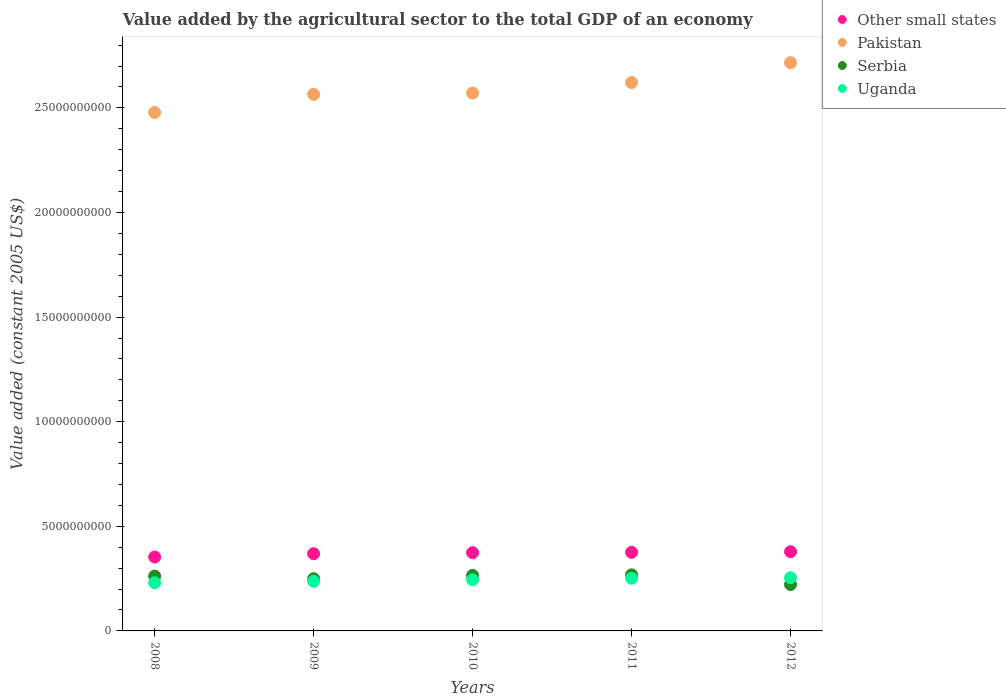How many different coloured dotlines are there?
Offer a very short reply. 4. Is the number of dotlines equal to the number of legend labels?
Provide a succinct answer. Yes. What is the value added by the agricultural sector in Pakistan in 2010?
Offer a very short reply. 2.57e+1. Across all years, what is the maximum value added by the agricultural sector in Pakistan?
Offer a terse response. 2.72e+1. Across all years, what is the minimum value added by the agricultural sector in Pakistan?
Your answer should be very brief. 2.48e+1. In which year was the value added by the agricultural sector in Other small states maximum?
Offer a very short reply. 2012. What is the total value added by the agricultural sector in Pakistan in the graph?
Provide a short and direct response. 1.30e+11. What is the difference between the value added by the agricultural sector in Uganda in 2009 and that in 2011?
Keep it short and to the point. -1.46e+08. What is the difference between the value added by the agricultural sector in Pakistan in 2011 and the value added by the agricultural sector in Other small states in 2008?
Provide a succinct answer. 2.27e+1. What is the average value added by the agricultural sector in Serbia per year?
Keep it short and to the point. 2.53e+09. In the year 2008, what is the difference between the value added by the agricultural sector in Other small states and value added by the agricultural sector in Serbia?
Your response must be concise. 9.11e+08. What is the ratio of the value added by the agricultural sector in Other small states in 2009 to that in 2010?
Give a very brief answer. 0.99. Is the difference between the value added by the agricultural sector in Other small states in 2010 and 2012 greater than the difference between the value added by the agricultural sector in Serbia in 2010 and 2012?
Your answer should be compact. No. What is the difference between the highest and the second highest value added by the agricultural sector in Serbia?
Make the answer very short. 2.52e+07. What is the difference between the highest and the lowest value added by the agricultural sector in Uganda?
Your answer should be compact. 2.40e+08. Is the sum of the value added by the agricultural sector in Serbia in 2011 and 2012 greater than the maximum value added by the agricultural sector in Pakistan across all years?
Provide a short and direct response. No. Is it the case that in every year, the sum of the value added by the agricultural sector in Pakistan and value added by the agricultural sector in Serbia  is greater than the sum of value added by the agricultural sector in Uganda and value added by the agricultural sector in Other small states?
Your answer should be very brief. Yes. Does the value added by the agricultural sector in Uganda monotonically increase over the years?
Ensure brevity in your answer.  Yes. Is the value added by the agricultural sector in Other small states strictly less than the value added by the agricultural sector in Uganda over the years?
Offer a very short reply. No. How many dotlines are there?
Your answer should be very brief. 4. Where does the legend appear in the graph?
Keep it short and to the point. Top right. How are the legend labels stacked?
Give a very brief answer. Vertical. What is the title of the graph?
Give a very brief answer. Value added by the agricultural sector to the total GDP of an economy. Does "OECD members" appear as one of the legend labels in the graph?
Keep it short and to the point. No. What is the label or title of the Y-axis?
Provide a short and direct response. Value added (constant 2005 US$). What is the Value added (constant 2005 US$) in Other small states in 2008?
Provide a succinct answer. 3.53e+09. What is the Value added (constant 2005 US$) of Pakistan in 2008?
Provide a short and direct response. 2.48e+1. What is the Value added (constant 2005 US$) in Serbia in 2008?
Keep it short and to the point. 2.62e+09. What is the Value added (constant 2005 US$) of Uganda in 2008?
Give a very brief answer. 2.30e+09. What is the Value added (constant 2005 US$) in Other small states in 2009?
Provide a succinct answer. 3.69e+09. What is the Value added (constant 2005 US$) in Pakistan in 2009?
Keep it short and to the point. 2.56e+1. What is the Value added (constant 2005 US$) of Serbia in 2009?
Give a very brief answer. 2.50e+09. What is the Value added (constant 2005 US$) in Uganda in 2009?
Provide a succinct answer. 2.37e+09. What is the Value added (constant 2005 US$) in Other small states in 2010?
Your response must be concise. 3.74e+09. What is the Value added (constant 2005 US$) of Pakistan in 2010?
Your answer should be compact. 2.57e+1. What is the Value added (constant 2005 US$) of Serbia in 2010?
Make the answer very short. 2.66e+09. What is the Value added (constant 2005 US$) in Uganda in 2010?
Offer a terse response. 2.45e+09. What is the Value added (constant 2005 US$) of Other small states in 2011?
Keep it short and to the point. 3.76e+09. What is the Value added (constant 2005 US$) in Pakistan in 2011?
Ensure brevity in your answer.  2.62e+1. What is the Value added (constant 2005 US$) in Serbia in 2011?
Provide a succinct answer. 2.68e+09. What is the Value added (constant 2005 US$) of Uganda in 2011?
Provide a short and direct response. 2.52e+09. What is the Value added (constant 2005 US$) of Other small states in 2012?
Offer a terse response. 3.79e+09. What is the Value added (constant 2005 US$) in Pakistan in 2012?
Ensure brevity in your answer.  2.72e+1. What is the Value added (constant 2005 US$) in Serbia in 2012?
Make the answer very short. 2.22e+09. What is the Value added (constant 2005 US$) in Uganda in 2012?
Offer a terse response. 2.54e+09. Across all years, what is the maximum Value added (constant 2005 US$) of Other small states?
Keep it short and to the point. 3.79e+09. Across all years, what is the maximum Value added (constant 2005 US$) of Pakistan?
Your response must be concise. 2.72e+1. Across all years, what is the maximum Value added (constant 2005 US$) in Serbia?
Provide a short and direct response. 2.68e+09. Across all years, what is the maximum Value added (constant 2005 US$) of Uganda?
Provide a short and direct response. 2.54e+09. Across all years, what is the minimum Value added (constant 2005 US$) in Other small states?
Provide a short and direct response. 3.53e+09. Across all years, what is the minimum Value added (constant 2005 US$) of Pakistan?
Make the answer very short. 2.48e+1. Across all years, what is the minimum Value added (constant 2005 US$) of Serbia?
Keep it short and to the point. 2.22e+09. Across all years, what is the minimum Value added (constant 2005 US$) of Uganda?
Your response must be concise. 2.30e+09. What is the total Value added (constant 2005 US$) of Other small states in the graph?
Offer a very short reply. 1.85e+1. What is the total Value added (constant 2005 US$) of Pakistan in the graph?
Your answer should be very brief. 1.30e+11. What is the total Value added (constant 2005 US$) in Serbia in the graph?
Provide a short and direct response. 1.27e+1. What is the total Value added (constant 2005 US$) of Uganda in the graph?
Make the answer very short. 1.22e+1. What is the difference between the Value added (constant 2005 US$) of Other small states in 2008 and that in 2009?
Offer a terse response. -1.59e+08. What is the difference between the Value added (constant 2005 US$) of Pakistan in 2008 and that in 2009?
Keep it short and to the point. -8.67e+08. What is the difference between the Value added (constant 2005 US$) of Serbia in 2008 and that in 2009?
Make the answer very short. 1.25e+08. What is the difference between the Value added (constant 2005 US$) in Uganda in 2008 and that in 2009?
Your answer should be very brief. -6.66e+07. What is the difference between the Value added (constant 2005 US$) of Other small states in 2008 and that in 2010?
Provide a short and direct response. -2.07e+08. What is the difference between the Value added (constant 2005 US$) in Pakistan in 2008 and that in 2010?
Give a very brief answer. -9.26e+08. What is the difference between the Value added (constant 2005 US$) of Serbia in 2008 and that in 2010?
Make the answer very short. -3.45e+07. What is the difference between the Value added (constant 2005 US$) of Uganda in 2008 and that in 2010?
Provide a succinct answer. -1.42e+08. What is the difference between the Value added (constant 2005 US$) in Other small states in 2008 and that in 2011?
Ensure brevity in your answer.  -2.24e+08. What is the difference between the Value added (constant 2005 US$) in Pakistan in 2008 and that in 2011?
Offer a terse response. -1.43e+09. What is the difference between the Value added (constant 2005 US$) of Serbia in 2008 and that in 2011?
Ensure brevity in your answer.  -5.97e+07. What is the difference between the Value added (constant 2005 US$) of Uganda in 2008 and that in 2011?
Ensure brevity in your answer.  -2.13e+08. What is the difference between the Value added (constant 2005 US$) in Other small states in 2008 and that in 2012?
Your answer should be very brief. -2.54e+08. What is the difference between the Value added (constant 2005 US$) of Pakistan in 2008 and that in 2012?
Ensure brevity in your answer.  -2.38e+09. What is the difference between the Value added (constant 2005 US$) of Serbia in 2008 and that in 2012?
Your response must be concise. 4.04e+08. What is the difference between the Value added (constant 2005 US$) in Uganda in 2008 and that in 2012?
Keep it short and to the point. -2.40e+08. What is the difference between the Value added (constant 2005 US$) of Other small states in 2009 and that in 2010?
Give a very brief answer. -4.82e+07. What is the difference between the Value added (constant 2005 US$) in Pakistan in 2009 and that in 2010?
Offer a very short reply. -5.89e+07. What is the difference between the Value added (constant 2005 US$) in Serbia in 2009 and that in 2010?
Provide a short and direct response. -1.59e+08. What is the difference between the Value added (constant 2005 US$) in Uganda in 2009 and that in 2010?
Your response must be concise. -7.50e+07. What is the difference between the Value added (constant 2005 US$) of Other small states in 2009 and that in 2011?
Make the answer very short. -6.47e+07. What is the difference between the Value added (constant 2005 US$) of Pakistan in 2009 and that in 2011?
Give a very brief answer. -5.63e+08. What is the difference between the Value added (constant 2005 US$) of Serbia in 2009 and that in 2011?
Make the answer very short. -1.85e+08. What is the difference between the Value added (constant 2005 US$) of Uganda in 2009 and that in 2011?
Your answer should be compact. -1.46e+08. What is the difference between the Value added (constant 2005 US$) in Other small states in 2009 and that in 2012?
Ensure brevity in your answer.  -9.50e+07. What is the difference between the Value added (constant 2005 US$) in Pakistan in 2009 and that in 2012?
Give a very brief answer. -1.51e+09. What is the difference between the Value added (constant 2005 US$) in Serbia in 2009 and that in 2012?
Ensure brevity in your answer.  2.79e+08. What is the difference between the Value added (constant 2005 US$) of Uganda in 2009 and that in 2012?
Give a very brief answer. -1.74e+08. What is the difference between the Value added (constant 2005 US$) of Other small states in 2010 and that in 2011?
Offer a very short reply. -1.65e+07. What is the difference between the Value added (constant 2005 US$) of Pakistan in 2010 and that in 2011?
Make the answer very short. -5.04e+08. What is the difference between the Value added (constant 2005 US$) in Serbia in 2010 and that in 2011?
Provide a succinct answer. -2.52e+07. What is the difference between the Value added (constant 2005 US$) in Uganda in 2010 and that in 2011?
Offer a very short reply. -7.14e+07. What is the difference between the Value added (constant 2005 US$) of Other small states in 2010 and that in 2012?
Your response must be concise. -4.68e+07. What is the difference between the Value added (constant 2005 US$) of Pakistan in 2010 and that in 2012?
Your answer should be very brief. -1.45e+09. What is the difference between the Value added (constant 2005 US$) of Serbia in 2010 and that in 2012?
Offer a terse response. 4.38e+08. What is the difference between the Value added (constant 2005 US$) in Uganda in 2010 and that in 2012?
Your answer should be compact. -9.88e+07. What is the difference between the Value added (constant 2005 US$) in Other small states in 2011 and that in 2012?
Your answer should be very brief. -3.03e+07. What is the difference between the Value added (constant 2005 US$) of Pakistan in 2011 and that in 2012?
Your answer should be very brief. -9.49e+08. What is the difference between the Value added (constant 2005 US$) of Serbia in 2011 and that in 2012?
Your answer should be very brief. 4.64e+08. What is the difference between the Value added (constant 2005 US$) in Uganda in 2011 and that in 2012?
Keep it short and to the point. -2.74e+07. What is the difference between the Value added (constant 2005 US$) in Other small states in 2008 and the Value added (constant 2005 US$) in Pakistan in 2009?
Offer a terse response. -2.21e+1. What is the difference between the Value added (constant 2005 US$) of Other small states in 2008 and the Value added (constant 2005 US$) of Serbia in 2009?
Your answer should be compact. 1.04e+09. What is the difference between the Value added (constant 2005 US$) of Other small states in 2008 and the Value added (constant 2005 US$) of Uganda in 2009?
Keep it short and to the point. 1.16e+09. What is the difference between the Value added (constant 2005 US$) of Pakistan in 2008 and the Value added (constant 2005 US$) of Serbia in 2009?
Provide a succinct answer. 2.23e+1. What is the difference between the Value added (constant 2005 US$) in Pakistan in 2008 and the Value added (constant 2005 US$) in Uganda in 2009?
Your answer should be very brief. 2.24e+1. What is the difference between the Value added (constant 2005 US$) of Serbia in 2008 and the Value added (constant 2005 US$) of Uganda in 2009?
Your response must be concise. 2.51e+08. What is the difference between the Value added (constant 2005 US$) of Other small states in 2008 and the Value added (constant 2005 US$) of Pakistan in 2010?
Your answer should be very brief. -2.22e+1. What is the difference between the Value added (constant 2005 US$) of Other small states in 2008 and the Value added (constant 2005 US$) of Serbia in 2010?
Ensure brevity in your answer.  8.77e+08. What is the difference between the Value added (constant 2005 US$) in Other small states in 2008 and the Value added (constant 2005 US$) in Uganda in 2010?
Provide a short and direct response. 1.09e+09. What is the difference between the Value added (constant 2005 US$) of Pakistan in 2008 and the Value added (constant 2005 US$) of Serbia in 2010?
Provide a short and direct response. 2.21e+1. What is the difference between the Value added (constant 2005 US$) in Pakistan in 2008 and the Value added (constant 2005 US$) in Uganda in 2010?
Give a very brief answer. 2.23e+1. What is the difference between the Value added (constant 2005 US$) in Serbia in 2008 and the Value added (constant 2005 US$) in Uganda in 2010?
Make the answer very short. 1.76e+08. What is the difference between the Value added (constant 2005 US$) in Other small states in 2008 and the Value added (constant 2005 US$) in Pakistan in 2011?
Provide a short and direct response. -2.27e+1. What is the difference between the Value added (constant 2005 US$) of Other small states in 2008 and the Value added (constant 2005 US$) of Serbia in 2011?
Offer a very short reply. 8.52e+08. What is the difference between the Value added (constant 2005 US$) of Other small states in 2008 and the Value added (constant 2005 US$) of Uganda in 2011?
Give a very brief answer. 1.02e+09. What is the difference between the Value added (constant 2005 US$) in Pakistan in 2008 and the Value added (constant 2005 US$) in Serbia in 2011?
Offer a terse response. 2.21e+1. What is the difference between the Value added (constant 2005 US$) in Pakistan in 2008 and the Value added (constant 2005 US$) in Uganda in 2011?
Your response must be concise. 2.23e+1. What is the difference between the Value added (constant 2005 US$) of Serbia in 2008 and the Value added (constant 2005 US$) of Uganda in 2011?
Provide a short and direct response. 1.04e+08. What is the difference between the Value added (constant 2005 US$) in Other small states in 2008 and the Value added (constant 2005 US$) in Pakistan in 2012?
Keep it short and to the point. -2.36e+1. What is the difference between the Value added (constant 2005 US$) in Other small states in 2008 and the Value added (constant 2005 US$) in Serbia in 2012?
Provide a short and direct response. 1.32e+09. What is the difference between the Value added (constant 2005 US$) in Other small states in 2008 and the Value added (constant 2005 US$) in Uganda in 2012?
Make the answer very short. 9.88e+08. What is the difference between the Value added (constant 2005 US$) in Pakistan in 2008 and the Value added (constant 2005 US$) in Serbia in 2012?
Your answer should be very brief. 2.26e+1. What is the difference between the Value added (constant 2005 US$) in Pakistan in 2008 and the Value added (constant 2005 US$) in Uganda in 2012?
Make the answer very short. 2.22e+1. What is the difference between the Value added (constant 2005 US$) in Serbia in 2008 and the Value added (constant 2005 US$) in Uganda in 2012?
Your answer should be compact. 7.69e+07. What is the difference between the Value added (constant 2005 US$) in Other small states in 2009 and the Value added (constant 2005 US$) in Pakistan in 2010?
Give a very brief answer. -2.20e+1. What is the difference between the Value added (constant 2005 US$) in Other small states in 2009 and the Value added (constant 2005 US$) in Serbia in 2010?
Offer a very short reply. 1.04e+09. What is the difference between the Value added (constant 2005 US$) in Other small states in 2009 and the Value added (constant 2005 US$) in Uganda in 2010?
Ensure brevity in your answer.  1.25e+09. What is the difference between the Value added (constant 2005 US$) in Pakistan in 2009 and the Value added (constant 2005 US$) in Serbia in 2010?
Ensure brevity in your answer.  2.30e+1. What is the difference between the Value added (constant 2005 US$) of Pakistan in 2009 and the Value added (constant 2005 US$) of Uganda in 2010?
Your answer should be compact. 2.32e+1. What is the difference between the Value added (constant 2005 US$) of Serbia in 2009 and the Value added (constant 2005 US$) of Uganda in 2010?
Your answer should be compact. 5.08e+07. What is the difference between the Value added (constant 2005 US$) in Other small states in 2009 and the Value added (constant 2005 US$) in Pakistan in 2011?
Your response must be concise. -2.25e+1. What is the difference between the Value added (constant 2005 US$) of Other small states in 2009 and the Value added (constant 2005 US$) of Serbia in 2011?
Give a very brief answer. 1.01e+09. What is the difference between the Value added (constant 2005 US$) of Other small states in 2009 and the Value added (constant 2005 US$) of Uganda in 2011?
Ensure brevity in your answer.  1.17e+09. What is the difference between the Value added (constant 2005 US$) in Pakistan in 2009 and the Value added (constant 2005 US$) in Serbia in 2011?
Give a very brief answer. 2.30e+1. What is the difference between the Value added (constant 2005 US$) in Pakistan in 2009 and the Value added (constant 2005 US$) in Uganda in 2011?
Ensure brevity in your answer.  2.31e+1. What is the difference between the Value added (constant 2005 US$) in Serbia in 2009 and the Value added (constant 2005 US$) in Uganda in 2011?
Provide a short and direct response. -2.07e+07. What is the difference between the Value added (constant 2005 US$) of Other small states in 2009 and the Value added (constant 2005 US$) of Pakistan in 2012?
Your answer should be compact. -2.35e+1. What is the difference between the Value added (constant 2005 US$) in Other small states in 2009 and the Value added (constant 2005 US$) in Serbia in 2012?
Provide a short and direct response. 1.47e+09. What is the difference between the Value added (constant 2005 US$) in Other small states in 2009 and the Value added (constant 2005 US$) in Uganda in 2012?
Offer a very short reply. 1.15e+09. What is the difference between the Value added (constant 2005 US$) of Pakistan in 2009 and the Value added (constant 2005 US$) of Serbia in 2012?
Offer a very short reply. 2.34e+1. What is the difference between the Value added (constant 2005 US$) in Pakistan in 2009 and the Value added (constant 2005 US$) in Uganda in 2012?
Your response must be concise. 2.31e+1. What is the difference between the Value added (constant 2005 US$) in Serbia in 2009 and the Value added (constant 2005 US$) in Uganda in 2012?
Your answer should be compact. -4.81e+07. What is the difference between the Value added (constant 2005 US$) in Other small states in 2010 and the Value added (constant 2005 US$) in Pakistan in 2011?
Make the answer very short. -2.25e+1. What is the difference between the Value added (constant 2005 US$) of Other small states in 2010 and the Value added (constant 2005 US$) of Serbia in 2011?
Keep it short and to the point. 1.06e+09. What is the difference between the Value added (constant 2005 US$) of Other small states in 2010 and the Value added (constant 2005 US$) of Uganda in 2011?
Provide a succinct answer. 1.22e+09. What is the difference between the Value added (constant 2005 US$) in Pakistan in 2010 and the Value added (constant 2005 US$) in Serbia in 2011?
Your answer should be very brief. 2.30e+1. What is the difference between the Value added (constant 2005 US$) of Pakistan in 2010 and the Value added (constant 2005 US$) of Uganda in 2011?
Keep it short and to the point. 2.32e+1. What is the difference between the Value added (constant 2005 US$) of Serbia in 2010 and the Value added (constant 2005 US$) of Uganda in 2011?
Your response must be concise. 1.39e+08. What is the difference between the Value added (constant 2005 US$) of Other small states in 2010 and the Value added (constant 2005 US$) of Pakistan in 2012?
Offer a very short reply. -2.34e+1. What is the difference between the Value added (constant 2005 US$) in Other small states in 2010 and the Value added (constant 2005 US$) in Serbia in 2012?
Offer a terse response. 1.52e+09. What is the difference between the Value added (constant 2005 US$) of Other small states in 2010 and the Value added (constant 2005 US$) of Uganda in 2012?
Make the answer very short. 1.20e+09. What is the difference between the Value added (constant 2005 US$) in Pakistan in 2010 and the Value added (constant 2005 US$) in Serbia in 2012?
Make the answer very short. 2.35e+1. What is the difference between the Value added (constant 2005 US$) of Pakistan in 2010 and the Value added (constant 2005 US$) of Uganda in 2012?
Offer a very short reply. 2.32e+1. What is the difference between the Value added (constant 2005 US$) of Serbia in 2010 and the Value added (constant 2005 US$) of Uganda in 2012?
Provide a succinct answer. 1.11e+08. What is the difference between the Value added (constant 2005 US$) of Other small states in 2011 and the Value added (constant 2005 US$) of Pakistan in 2012?
Keep it short and to the point. -2.34e+1. What is the difference between the Value added (constant 2005 US$) in Other small states in 2011 and the Value added (constant 2005 US$) in Serbia in 2012?
Your response must be concise. 1.54e+09. What is the difference between the Value added (constant 2005 US$) in Other small states in 2011 and the Value added (constant 2005 US$) in Uganda in 2012?
Offer a terse response. 1.21e+09. What is the difference between the Value added (constant 2005 US$) of Pakistan in 2011 and the Value added (constant 2005 US$) of Serbia in 2012?
Provide a short and direct response. 2.40e+1. What is the difference between the Value added (constant 2005 US$) of Pakistan in 2011 and the Value added (constant 2005 US$) of Uganda in 2012?
Provide a succinct answer. 2.37e+1. What is the difference between the Value added (constant 2005 US$) of Serbia in 2011 and the Value added (constant 2005 US$) of Uganda in 2012?
Keep it short and to the point. 1.37e+08. What is the average Value added (constant 2005 US$) in Other small states per year?
Your answer should be very brief. 3.70e+09. What is the average Value added (constant 2005 US$) in Pakistan per year?
Make the answer very short. 2.59e+1. What is the average Value added (constant 2005 US$) in Serbia per year?
Provide a succinct answer. 2.53e+09. What is the average Value added (constant 2005 US$) in Uganda per year?
Keep it short and to the point. 2.44e+09. In the year 2008, what is the difference between the Value added (constant 2005 US$) in Other small states and Value added (constant 2005 US$) in Pakistan?
Ensure brevity in your answer.  -2.12e+1. In the year 2008, what is the difference between the Value added (constant 2005 US$) in Other small states and Value added (constant 2005 US$) in Serbia?
Your response must be concise. 9.11e+08. In the year 2008, what is the difference between the Value added (constant 2005 US$) in Other small states and Value added (constant 2005 US$) in Uganda?
Your response must be concise. 1.23e+09. In the year 2008, what is the difference between the Value added (constant 2005 US$) in Pakistan and Value added (constant 2005 US$) in Serbia?
Offer a very short reply. 2.22e+1. In the year 2008, what is the difference between the Value added (constant 2005 US$) in Pakistan and Value added (constant 2005 US$) in Uganda?
Your response must be concise. 2.25e+1. In the year 2008, what is the difference between the Value added (constant 2005 US$) of Serbia and Value added (constant 2005 US$) of Uganda?
Offer a very short reply. 3.17e+08. In the year 2009, what is the difference between the Value added (constant 2005 US$) in Other small states and Value added (constant 2005 US$) in Pakistan?
Provide a short and direct response. -2.20e+1. In the year 2009, what is the difference between the Value added (constant 2005 US$) of Other small states and Value added (constant 2005 US$) of Serbia?
Your answer should be compact. 1.20e+09. In the year 2009, what is the difference between the Value added (constant 2005 US$) of Other small states and Value added (constant 2005 US$) of Uganda?
Make the answer very short. 1.32e+09. In the year 2009, what is the difference between the Value added (constant 2005 US$) in Pakistan and Value added (constant 2005 US$) in Serbia?
Keep it short and to the point. 2.32e+1. In the year 2009, what is the difference between the Value added (constant 2005 US$) in Pakistan and Value added (constant 2005 US$) in Uganda?
Provide a short and direct response. 2.33e+1. In the year 2009, what is the difference between the Value added (constant 2005 US$) in Serbia and Value added (constant 2005 US$) in Uganda?
Your response must be concise. 1.26e+08. In the year 2010, what is the difference between the Value added (constant 2005 US$) of Other small states and Value added (constant 2005 US$) of Pakistan?
Make the answer very short. -2.20e+1. In the year 2010, what is the difference between the Value added (constant 2005 US$) in Other small states and Value added (constant 2005 US$) in Serbia?
Your answer should be compact. 1.08e+09. In the year 2010, what is the difference between the Value added (constant 2005 US$) of Other small states and Value added (constant 2005 US$) of Uganda?
Your answer should be compact. 1.29e+09. In the year 2010, what is the difference between the Value added (constant 2005 US$) in Pakistan and Value added (constant 2005 US$) in Serbia?
Your response must be concise. 2.31e+1. In the year 2010, what is the difference between the Value added (constant 2005 US$) of Pakistan and Value added (constant 2005 US$) of Uganda?
Offer a terse response. 2.33e+1. In the year 2010, what is the difference between the Value added (constant 2005 US$) of Serbia and Value added (constant 2005 US$) of Uganda?
Your answer should be very brief. 2.10e+08. In the year 2011, what is the difference between the Value added (constant 2005 US$) of Other small states and Value added (constant 2005 US$) of Pakistan?
Provide a succinct answer. -2.25e+1. In the year 2011, what is the difference between the Value added (constant 2005 US$) in Other small states and Value added (constant 2005 US$) in Serbia?
Make the answer very short. 1.08e+09. In the year 2011, what is the difference between the Value added (constant 2005 US$) in Other small states and Value added (constant 2005 US$) in Uganda?
Make the answer very short. 1.24e+09. In the year 2011, what is the difference between the Value added (constant 2005 US$) of Pakistan and Value added (constant 2005 US$) of Serbia?
Offer a very short reply. 2.35e+1. In the year 2011, what is the difference between the Value added (constant 2005 US$) of Pakistan and Value added (constant 2005 US$) of Uganda?
Make the answer very short. 2.37e+1. In the year 2011, what is the difference between the Value added (constant 2005 US$) of Serbia and Value added (constant 2005 US$) of Uganda?
Your answer should be very brief. 1.64e+08. In the year 2012, what is the difference between the Value added (constant 2005 US$) of Other small states and Value added (constant 2005 US$) of Pakistan?
Your answer should be very brief. -2.34e+1. In the year 2012, what is the difference between the Value added (constant 2005 US$) in Other small states and Value added (constant 2005 US$) in Serbia?
Offer a terse response. 1.57e+09. In the year 2012, what is the difference between the Value added (constant 2005 US$) of Other small states and Value added (constant 2005 US$) of Uganda?
Provide a succinct answer. 1.24e+09. In the year 2012, what is the difference between the Value added (constant 2005 US$) of Pakistan and Value added (constant 2005 US$) of Serbia?
Make the answer very short. 2.49e+1. In the year 2012, what is the difference between the Value added (constant 2005 US$) of Pakistan and Value added (constant 2005 US$) of Uganda?
Keep it short and to the point. 2.46e+1. In the year 2012, what is the difference between the Value added (constant 2005 US$) of Serbia and Value added (constant 2005 US$) of Uganda?
Ensure brevity in your answer.  -3.27e+08. What is the ratio of the Value added (constant 2005 US$) of Other small states in 2008 to that in 2009?
Your response must be concise. 0.96. What is the ratio of the Value added (constant 2005 US$) in Pakistan in 2008 to that in 2009?
Provide a succinct answer. 0.97. What is the ratio of the Value added (constant 2005 US$) of Serbia in 2008 to that in 2009?
Offer a very short reply. 1.05. What is the ratio of the Value added (constant 2005 US$) in Uganda in 2008 to that in 2009?
Provide a succinct answer. 0.97. What is the ratio of the Value added (constant 2005 US$) in Other small states in 2008 to that in 2010?
Your response must be concise. 0.94. What is the ratio of the Value added (constant 2005 US$) in Pakistan in 2008 to that in 2010?
Your response must be concise. 0.96. What is the ratio of the Value added (constant 2005 US$) in Serbia in 2008 to that in 2010?
Offer a terse response. 0.99. What is the ratio of the Value added (constant 2005 US$) of Uganda in 2008 to that in 2010?
Your answer should be compact. 0.94. What is the ratio of the Value added (constant 2005 US$) of Other small states in 2008 to that in 2011?
Make the answer very short. 0.94. What is the ratio of the Value added (constant 2005 US$) in Pakistan in 2008 to that in 2011?
Make the answer very short. 0.95. What is the ratio of the Value added (constant 2005 US$) of Serbia in 2008 to that in 2011?
Your answer should be compact. 0.98. What is the ratio of the Value added (constant 2005 US$) in Uganda in 2008 to that in 2011?
Provide a succinct answer. 0.92. What is the ratio of the Value added (constant 2005 US$) in Other small states in 2008 to that in 2012?
Your answer should be very brief. 0.93. What is the ratio of the Value added (constant 2005 US$) in Pakistan in 2008 to that in 2012?
Your response must be concise. 0.91. What is the ratio of the Value added (constant 2005 US$) of Serbia in 2008 to that in 2012?
Provide a short and direct response. 1.18. What is the ratio of the Value added (constant 2005 US$) of Uganda in 2008 to that in 2012?
Your answer should be very brief. 0.91. What is the ratio of the Value added (constant 2005 US$) in Other small states in 2009 to that in 2010?
Offer a terse response. 0.99. What is the ratio of the Value added (constant 2005 US$) of Uganda in 2009 to that in 2010?
Your answer should be compact. 0.97. What is the ratio of the Value added (constant 2005 US$) in Other small states in 2009 to that in 2011?
Your answer should be compact. 0.98. What is the ratio of the Value added (constant 2005 US$) of Pakistan in 2009 to that in 2011?
Keep it short and to the point. 0.98. What is the ratio of the Value added (constant 2005 US$) in Serbia in 2009 to that in 2011?
Your answer should be very brief. 0.93. What is the ratio of the Value added (constant 2005 US$) of Uganda in 2009 to that in 2011?
Keep it short and to the point. 0.94. What is the ratio of the Value added (constant 2005 US$) in Other small states in 2009 to that in 2012?
Offer a terse response. 0.97. What is the ratio of the Value added (constant 2005 US$) of Pakistan in 2009 to that in 2012?
Ensure brevity in your answer.  0.94. What is the ratio of the Value added (constant 2005 US$) in Serbia in 2009 to that in 2012?
Ensure brevity in your answer.  1.13. What is the ratio of the Value added (constant 2005 US$) of Uganda in 2009 to that in 2012?
Provide a succinct answer. 0.93. What is the ratio of the Value added (constant 2005 US$) of Other small states in 2010 to that in 2011?
Provide a succinct answer. 1. What is the ratio of the Value added (constant 2005 US$) of Pakistan in 2010 to that in 2011?
Give a very brief answer. 0.98. What is the ratio of the Value added (constant 2005 US$) in Serbia in 2010 to that in 2011?
Keep it short and to the point. 0.99. What is the ratio of the Value added (constant 2005 US$) in Uganda in 2010 to that in 2011?
Your answer should be very brief. 0.97. What is the ratio of the Value added (constant 2005 US$) in Other small states in 2010 to that in 2012?
Provide a short and direct response. 0.99. What is the ratio of the Value added (constant 2005 US$) of Pakistan in 2010 to that in 2012?
Make the answer very short. 0.95. What is the ratio of the Value added (constant 2005 US$) of Serbia in 2010 to that in 2012?
Provide a succinct answer. 1.2. What is the ratio of the Value added (constant 2005 US$) of Uganda in 2010 to that in 2012?
Offer a terse response. 0.96. What is the ratio of the Value added (constant 2005 US$) in Serbia in 2011 to that in 2012?
Keep it short and to the point. 1.21. What is the difference between the highest and the second highest Value added (constant 2005 US$) of Other small states?
Make the answer very short. 3.03e+07. What is the difference between the highest and the second highest Value added (constant 2005 US$) of Pakistan?
Make the answer very short. 9.49e+08. What is the difference between the highest and the second highest Value added (constant 2005 US$) of Serbia?
Your response must be concise. 2.52e+07. What is the difference between the highest and the second highest Value added (constant 2005 US$) in Uganda?
Your answer should be very brief. 2.74e+07. What is the difference between the highest and the lowest Value added (constant 2005 US$) of Other small states?
Ensure brevity in your answer.  2.54e+08. What is the difference between the highest and the lowest Value added (constant 2005 US$) of Pakistan?
Your answer should be very brief. 2.38e+09. What is the difference between the highest and the lowest Value added (constant 2005 US$) of Serbia?
Provide a short and direct response. 4.64e+08. What is the difference between the highest and the lowest Value added (constant 2005 US$) of Uganda?
Provide a short and direct response. 2.40e+08. 